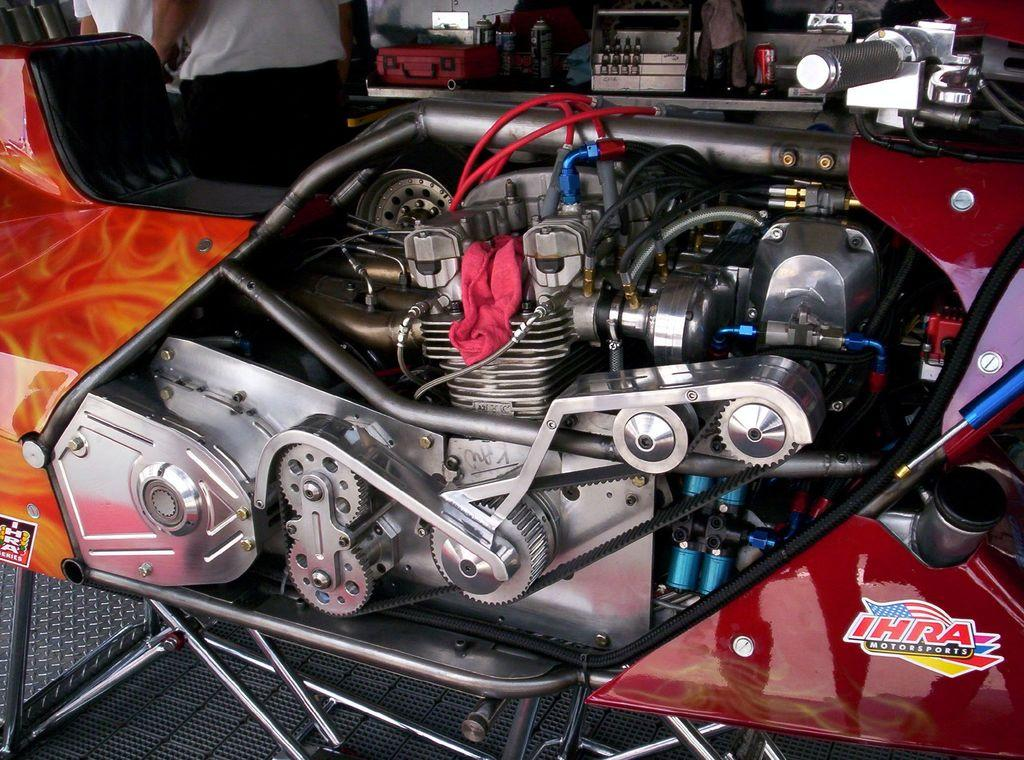What is the main subject of the image? The main subject of the image is an engine. Are there any other vehicle components visible in the image? Yes, there are other parts of a vehicle in the image. Can you describe the people in the image? There are two people at the top of the image, but they are truncated. What type of bell can be heard ringing in the image? There is no bell present in the image, and therefore no sound can be heard. 